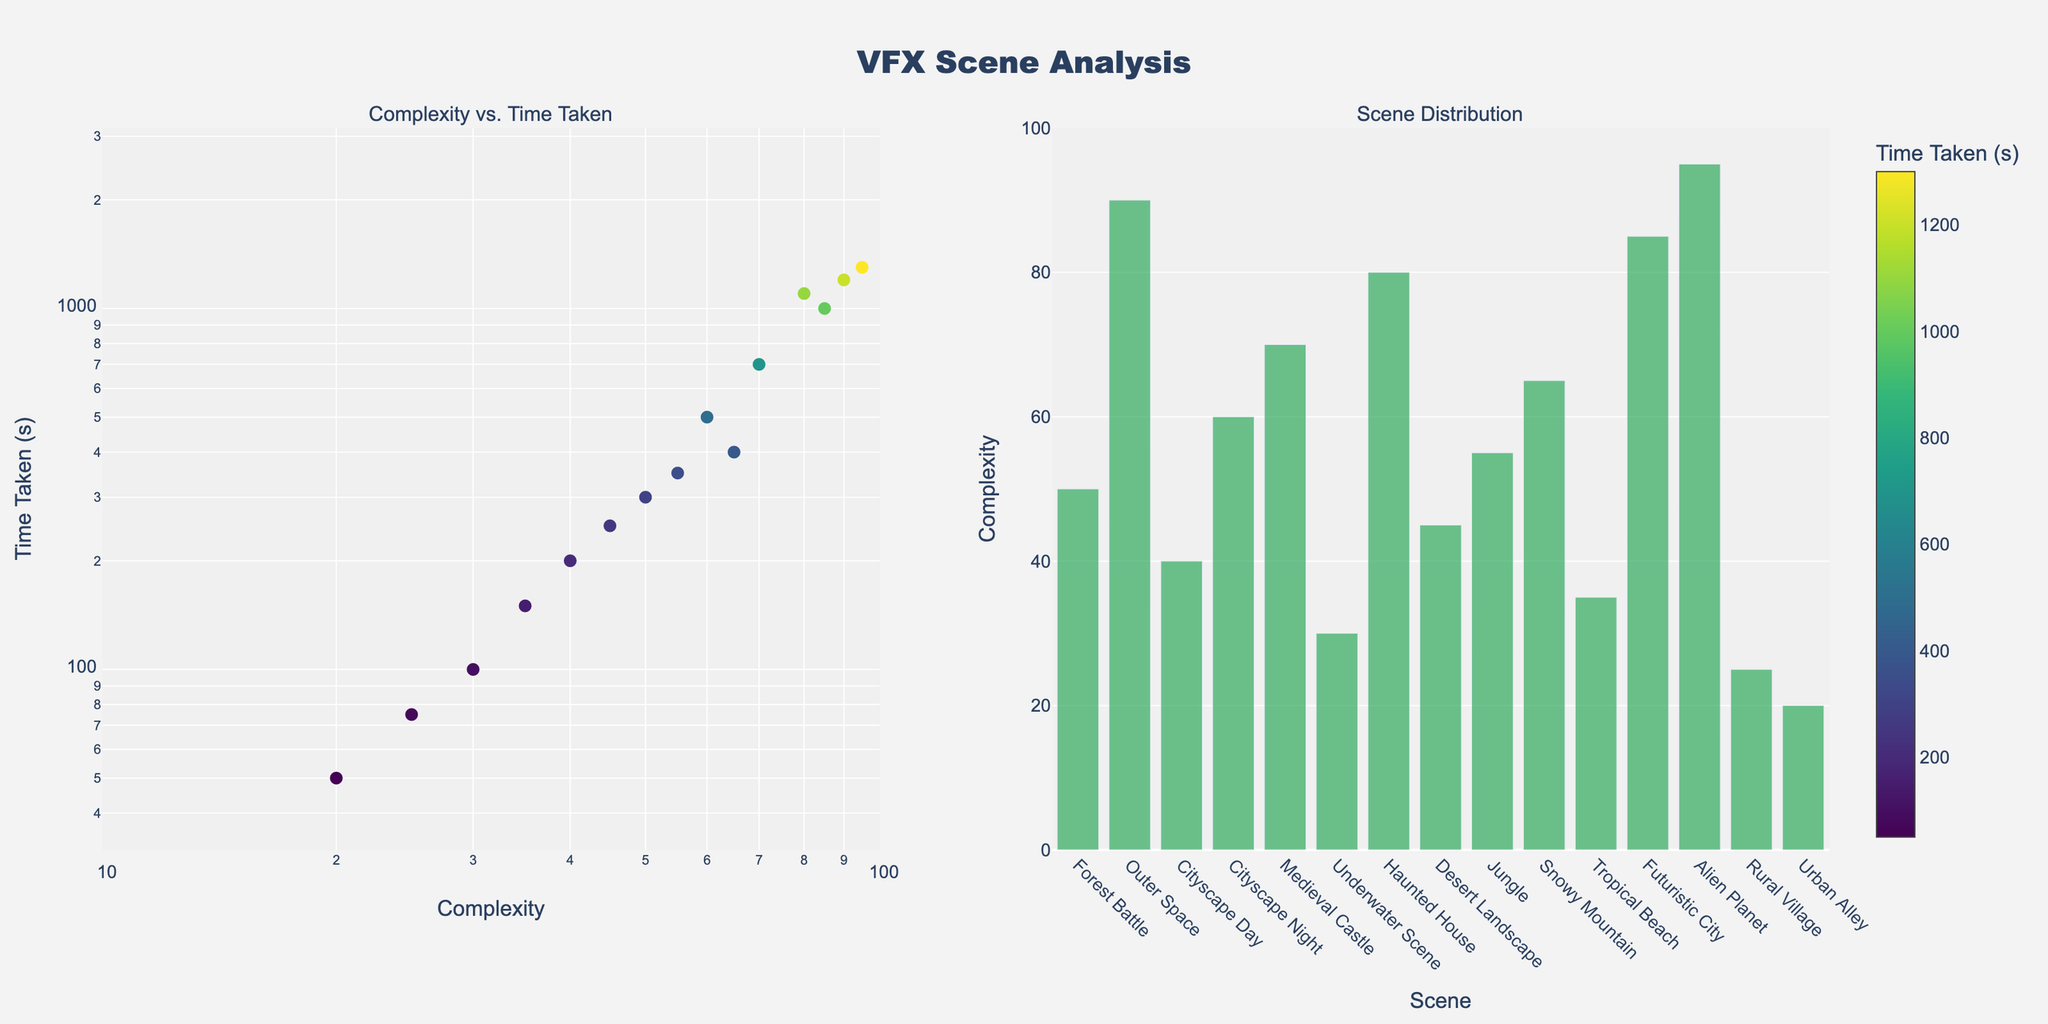What's the title of the overall figure? The title is positioned at the top center of the figure. It reads "VFX Scene Analysis".
Answer: VFX Scene Analysis How many scenes have a Complexity value over 70? Count the number of bars in the right subplot where the Complexity value is over 70. These scenes are "Outer Space", "Alien Planet", "Haunted House", "Futuristic City".
Answer: 4 Which scene takes the least amount of time for rendering? In the left subplot, the marker at the lowest y-axis value represents the least time taken, labeled as "Urban Alley" with 50 seconds.
Answer: Urban Alley What is the relationship between scene "Outer Space" and "Alien Planet" in terms of Complexity and Time Taken? "Outer Space" has a Complexity of 90 and Time Taken of 1200 seconds. "Alien Planet" has a Complexity of 95 and Time Taken of 1300 seconds. Comparing these, "Alien Planet" has higher values in both Complexity and Time Taken.
Answer: Alien Planet is more complex and takes more time than Outer Space Which scene has the highest Complexity value? In the right subplot, the bar chart reaches the highest point for the scene "Alien Planet".
Answer: Alien Planet Are there more scenes with Complexity values below 50 or above 50? Count the number of bars below and above the middle point (50) in the right subplot. The scenes with Complexity below 50 are 6, and those above 50 are 8.
Answer: More scenes above 50 What colorscale is used for the markers in the scatter plot? The color of the markers corresponds to the Time Taken and follows the Viridis colorscale, as indicated by the colorscale legend on the left subplot.
Answer: Viridis What is the Complexity range displayed in the scatter plot? The x-axis of the scatter plot uses a log scale with a range from 1 to 2, which corresponds to a Complexity range of 10^1 (10) to 10^2 (100).
Answer: 10 to 100 What scene's Complexity and Time Taken values are closest to the logarithmic midpoint of the displayed range in the scatter plot? The midpoint in log scale for both Complexity and Time Taken ranges can be derived from the geometric mean of the bounds (Complexity: sqrt(10*100), Time Taken: sqrt(10^1.5*10^3.5)). The values closest to these midpoints are for "Cityscape Night" and "Snowy Mountain".
Answer: Cityscape Night and Snowy Mountain 